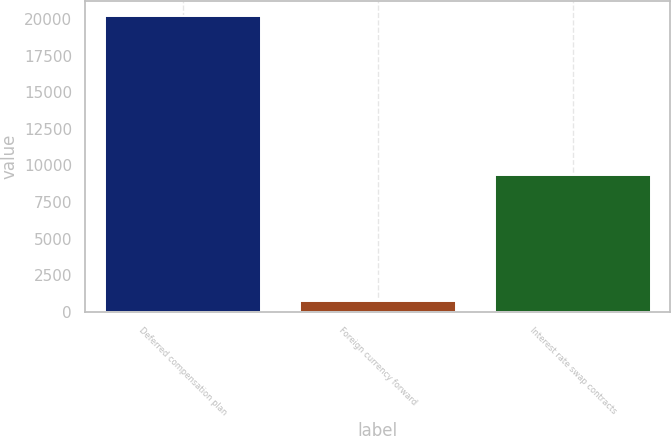Convert chart to OTSL. <chart><loc_0><loc_0><loc_500><loc_500><bar_chart><fcel>Deferred compensation plan<fcel>Foreign currency forward<fcel>Interest rate swap contracts<nl><fcel>20214<fcel>740<fcel>9363<nl></chart> 